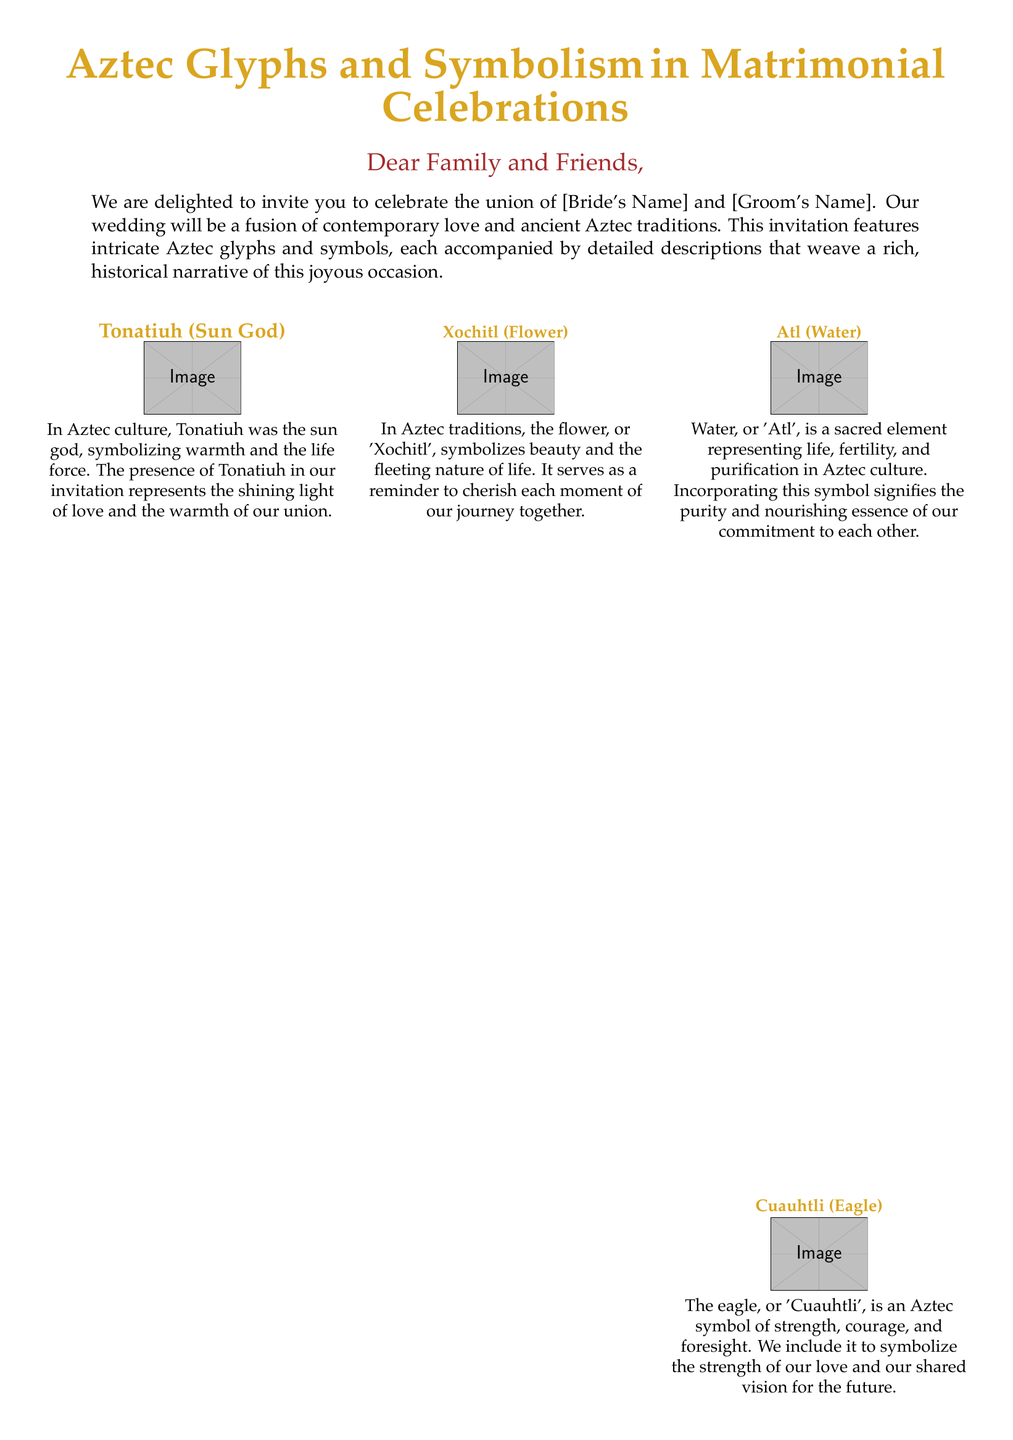What are the names of the couple? The couple's names are presented at the end of the invitation.
Answer: [Bride's Name] and [Groom's Name] What does the symbol 'Xochitl' represent? The symbol 'Xochitl' in the document is described to symbolize beauty and the fleeting nature of life.
Answer: Beauty and the fleeting nature of life Which Aztec symbol represents strength and foresight? The document states that the eagle, or 'Cuauhtli', is a symbol of strength and foresight.
Answer: Cuauhtli How many symbols are described in the document? The document lists a total of six symbols with descriptions.
Answer: Six What is the color code for 'aztecgold'? The document defines the color 'aztecgold' using RGB values.
Answer: 218,165,32 What element is represented by 'Atl'? The glyph 'Atl' is described as representing life, fertility, and purification.
Answer: Life, fertility, and purification Why is 'Ollin' significant in the invitation? The glyph 'Ollin' represents movement, change, and life, echoing their journey together.
Answer: Movement, change, and life What do the couple's wedding invite encompass? The invitation encompasses a blend of contemporary love and ancient Aztec traditions.
Answer: Contemporary love and ancient Aztec traditions 